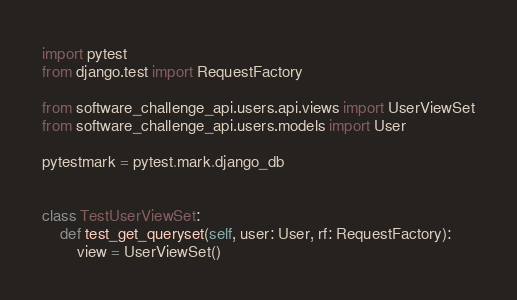Convert code to text. <code><loc_0><loc_0><loc_500><loc_500><_Python_>import pytest
from django.test import RequestFactory

from software_challenge_api.users.api.views import UserViewSet
from software_challenge_api.users.models import User

pytestmark = pytest.mark.django_db


class TestUserViewSet:
    def test_get_queryset(self, user: User, rf: RequestFactory):
        view = UserViewSet()</code> 